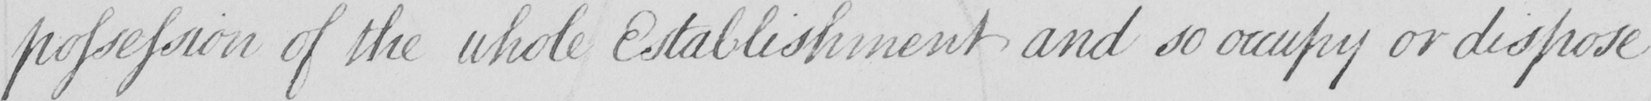What does this handwritten line say? possession of the whole Establishment and so occupy or dispose 